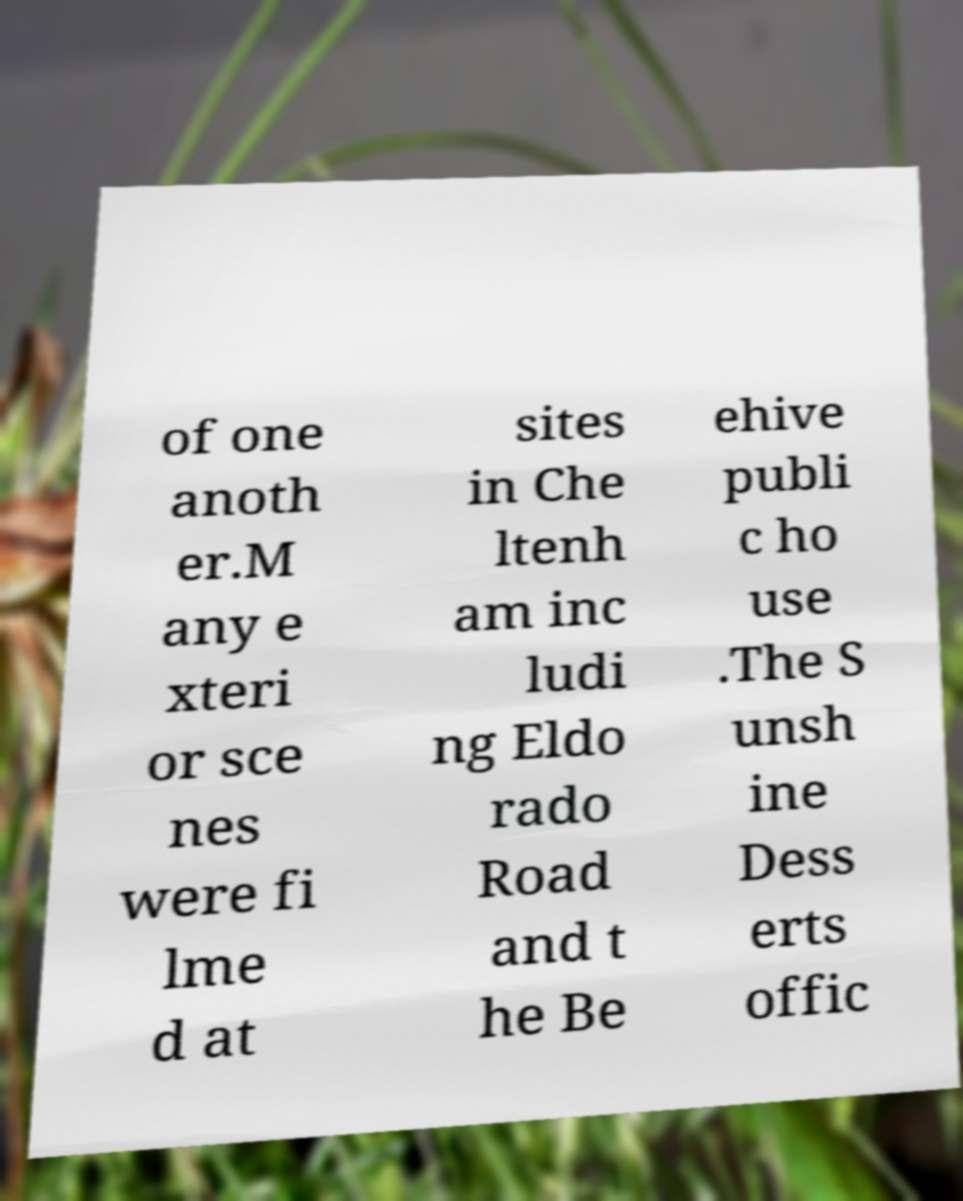Please identify and transcribe the text found in this image. of one anoth er.M any e xteri or sce nes were fi lme d at sites in Che ltenh am inc ludi ng Eldo rado Road and t he Be ehive publi c ho use .The S unsh ine Dess erts offic 